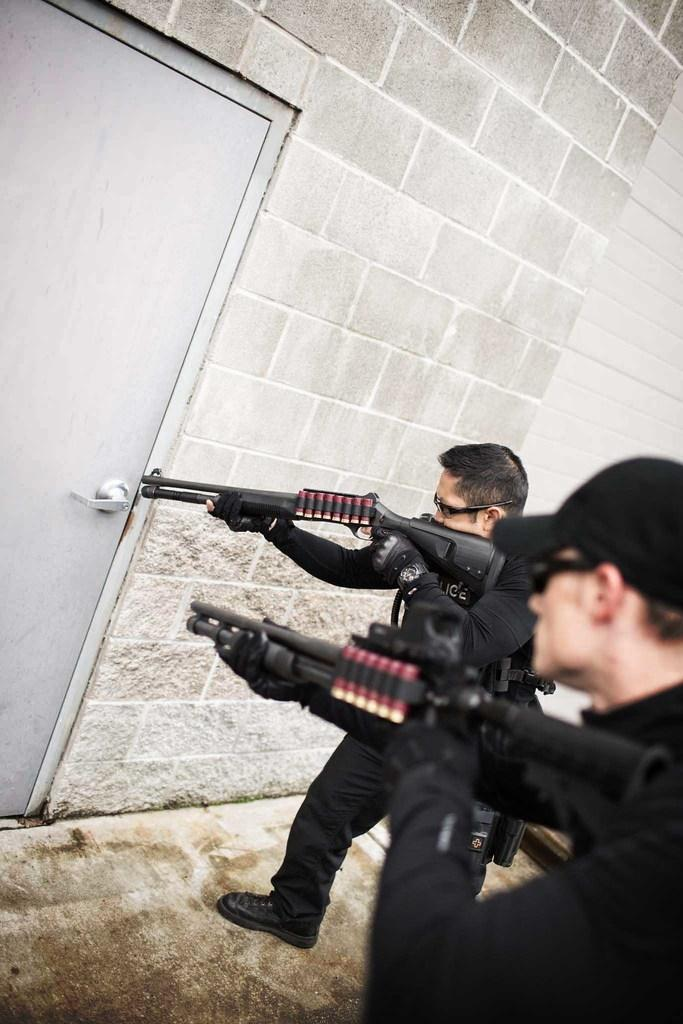How many men are present in the image? There are two men standing on the right side of the image. What are the men holding in their hands? The men are holding guns in their hands. Can you describe the appearance of one of the men? There is a man with a cap on his head. What is in front of the men? There is a wall with a door in front of the men. What type of patch is sewn onto the man's shirt in the image? There is no patch visible on the man's shirt in the image. How many weeks have passed since the event depicted in the image? The image does not provide any information about the timing or duration of the event. 